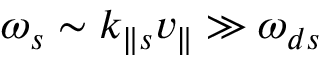<formula> <loc_0><loc_0><loc_500><loc_500>\omega _ { s } \sim k _ { \| s } v _ { \| } \gg \omega _ { d s }</formula> 